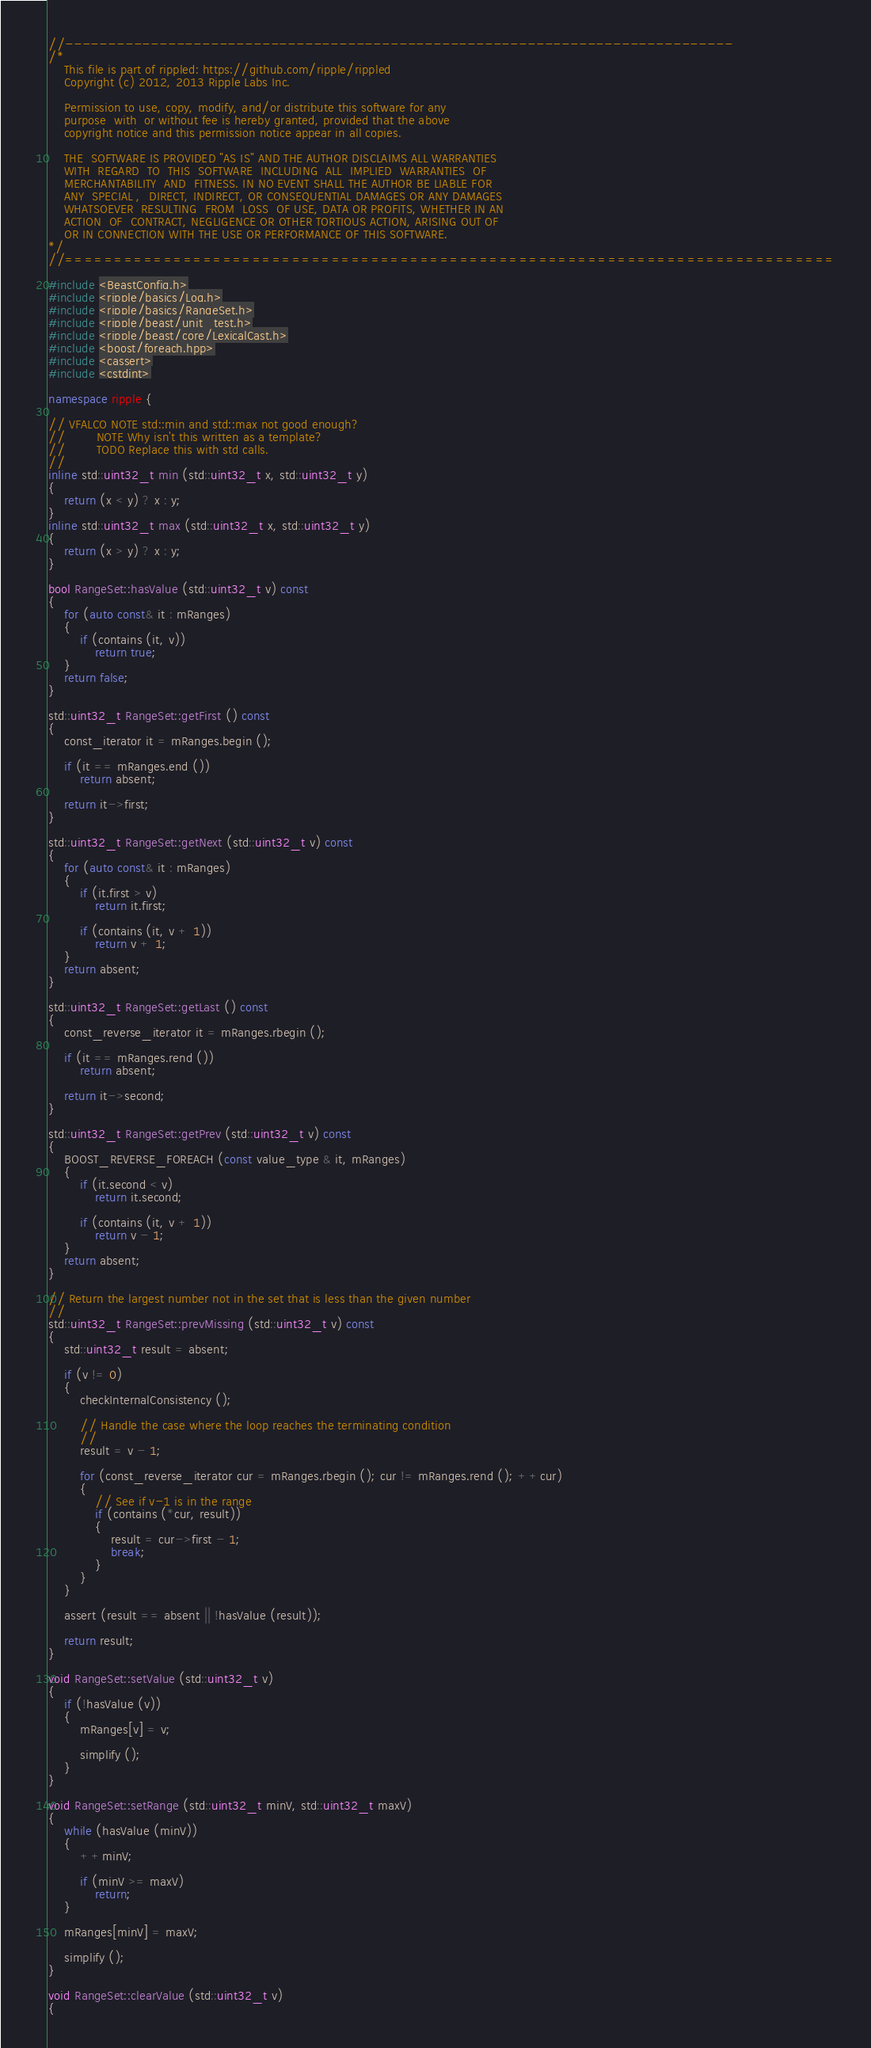Convert code to text. <code><loc_0><loc_0><loc_500><loc_500><_C++_>//------------------------------------------------------------------------------
/*
    This file is part of rippled: https://github.com/ripple/rippled
    Copyright (c) 2012, 2013 Ripple Labs Inc.

    Permission to use, copy, modify, and/or distribute this software for any
    purpose  with  or without fee is hereby granted, provided that the above
    copyright notice and this permission notice appear in all copies.

    THE  SOFTWARE IS PROVIDED "AS IS" AND THE AUTHOR DISCLAIMS ALL WARRANTIES
    WITH  REGARD  TO  THIS  SOFTWARE  INCLUDING  ALL  IMPLIED  WARRANTIES  OF
    MERCHANTABILITY  AND  FITNESS. IN NO EVENT SHALL THE AUTHOR BE LIABLE FOR
    ANY  SPECIAL ,  DIRECT, INDIRECT, OR CONSEQUENTIAL DAMAGES OR ANY DAMAGES
    WHATSOEVER  RESULTING  FROM  LOSS  OF USE, DATA OR PROFITS, WHETHER IN AN
    ACTION  OF  CONTRACT, NEGLIGENCE OR OTHER TORTIOUS ACTION, ARISING OUT OF
    OR IN CONNECTION WITH THE USE OR PERFORMANCE OF THIS SOFTWARE.
*/
//==============================================================================

#include <BeastConfig.h>
#include <ripple/basics/Log.h>
#include <ripple/basics/RangeSet.h>
#include <ripple/beast/unit_test.h>
#include <ripple/beast/core/LexicalCast.h>
#include <boost/foreach.hpp>
#include <cassert>
#include <cstdint>

namespace ripple {

// VFALCO NOTE std::min and std::max not good enough?
//        NOTE Why isn't this written as a template?
//        TODO Replace this with std calls.
//
inline std::uint32_t min (std::uint32_t x, std::uint32_t y)
{
    return (x < y) ? x : y;
}
inline std::uint32_t max (std::uint32_t x, std::uint32_t y)
{
    return (x > y) ? x : y;
}

bool RangeSet::hasValue (std::uint32_t v) const
{
    for (auto const& it : mRanges)
    {
        if (contains (it, v))
            return true;
    }
    return false;
}

std::uint32_t RangeSet::getFirst () const
{
    const_iterator it = mRanges.begin ();

    if (it == mRanges.end ())
        return absent;

    return it->first;
}

std::uint32_t RangeSet::getNext (std::uint32_t v) const
{
    for (auto const& it : mRanges)
    {
        if (it.first > v)
            return it.first;

        if (contains (it, v + 1))
            return v + 1;
    }
    return absent;
}

std::uint32_t RangeSet::getLast () const
{
    const_reverse_iterator it = mRanges.rbegin ();

    if (it == mRanges.rend ())
        return absent;

    return it->second;
}

std::uint32_t RangeSet::getPrev (std::uint32_t v) const
{
    BOOST_REVERSE_FOREACH (const value_type & it, mRanges)
    {
        if (it.second < v)
            return it.second;

        if (contains (it, v + 1))
            return v - 1;
    }
    return absent;
}

// Return the largest number not in the set that is less than the given number
//
std::uint32_t RangeSet::prevMissing (std::uint32_t v) const
{
    std::uint32_t result = absent;

    if (v != 0)
    {
        checkInternalConsistency ();

        // Handle the case where the loop reaches the terminating condition
        //
        result = v - 1;

        for (const_reverse_iterator cur = mRanges.rbegin (); cur != mRanges.rend (); ++cur)
        {
            // See if v-1 is in the range
            if (contains (*cur, result))
            {
                result = cur->first - 1;
                break;
            }
        }
    }

    assert (result == absent || !hasValue (result));

    return result;
}

void RangeSet::setValue (std::uint32_t v)
{
    if (!hasValue (v))
    {
        mRanges[v] = v;

        simplify ();
    }
}

void RangeSet::setRange (std::uint32_t minV, std::uint32_t maxV)
{
    while (hasValue (minV))
    {
        ++minV;

        if (minV >= maxV)
            return;
    }

    mRanges[minV] = maxV;

    simplify ();
}

void RangeSet::clearValue (std::uint32_t v)
{</code> 